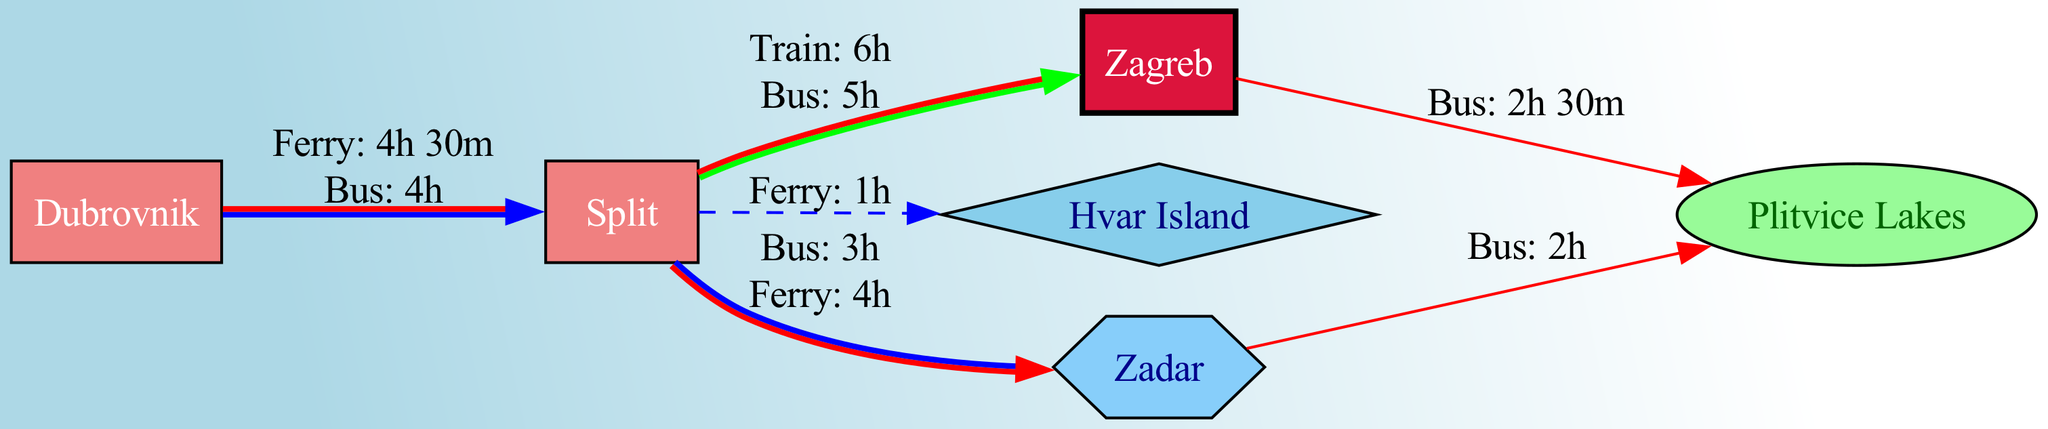What are the tourist destinations represented as nodes in the diagram? The diagram features nodes representing tourist destinations: Dubrovnik, Split, Zagreb, Plitvice Lakes, Hvar Island, and Zadar.
Answer: Dubrovnik, Split, Zagreb, Plitvice Lakes, Hvar Island, Zadar How many edges represent transportation options? The diagram contains edges that represent various transport connections between destinations. There are a total of 6 edges present.
Answer: 6 What type of transportation connects Split and Hvar Island? The edge between Split and Hvar Island indicates a ferry connection, specified as "Ferry: 1h."
Answer: Ferry What is the travel time from Dubrovnik to Split by bus? The edge from Dubrovnik to Split indicates a bus travel time of 4 hours.
Answer: 4h Which destination can be reached from Zagreb in the shortest travel time? By examining the edges, the shortest travel time from Zagreb is to Plitvice Lakes with a bus time of 2 hours 30 minutes.
Answer: Plitvice Lakes What types of relationships exist between Dubrovnik and Split? The relationship between Dubrovnik and Split is defined by both a ferry and a bus connection, indicating options for sea and road transport.
Answer: Sea/Road Which city is connected to Plitvice Lakes by bus from Zadar? The diagram shows an edge indicating that Zadar is connected to Plitvice Lakes by bus, with a travel time of 2 hours.
Answer: Zadar What kind of node is Zagreb classified as? In the diagram, Zagreb is classified as a "Capital City," distinguishing its significance among other destinations.
Answer: Capital City What is the travel time and mode of transport from Split to Zadar? The diagram indicates that traveling from Split to Zadar can be done by bus, taking 3 hours, or by ferry, taking 4 hours.
Answer: 3h, Ferry 4h 